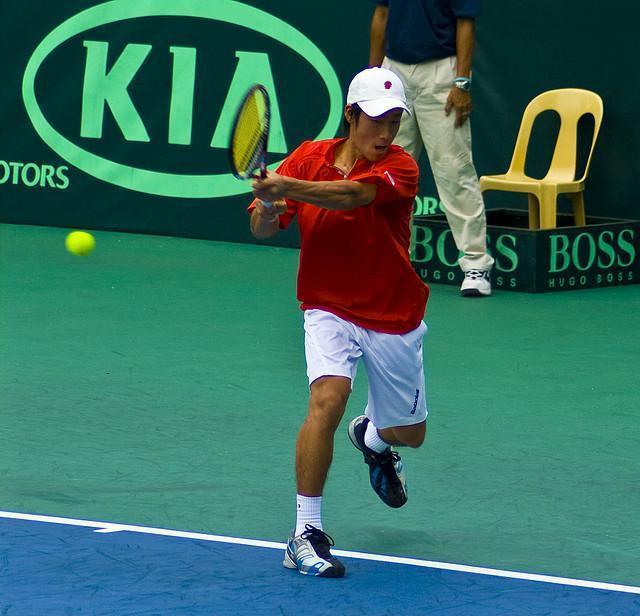How many people are in the photo?
Give a very brief answer. 2. How many chairs are in the photo?
Give a very brief answer. 1. How many cows are located in this picture?
Give a very brief answer. 0. 